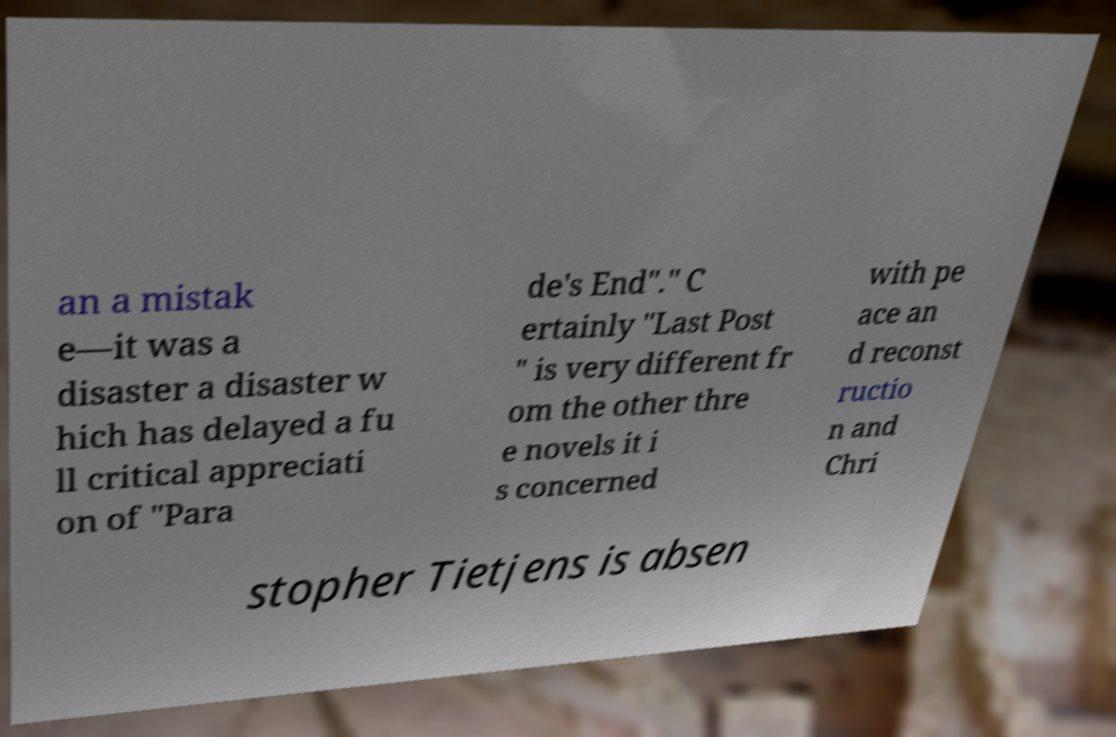Could you extract and type out the text from this image? an a mistak e—it was a disaster a disaster w hich has delayed a fu ll critical appreciati on of "Para de's End"." C ertainly "Last Post " is very different fr om the other thre e novels it i s concerned with pe ace an d reconst ructio n and Chri stopher Tietjens is absen 